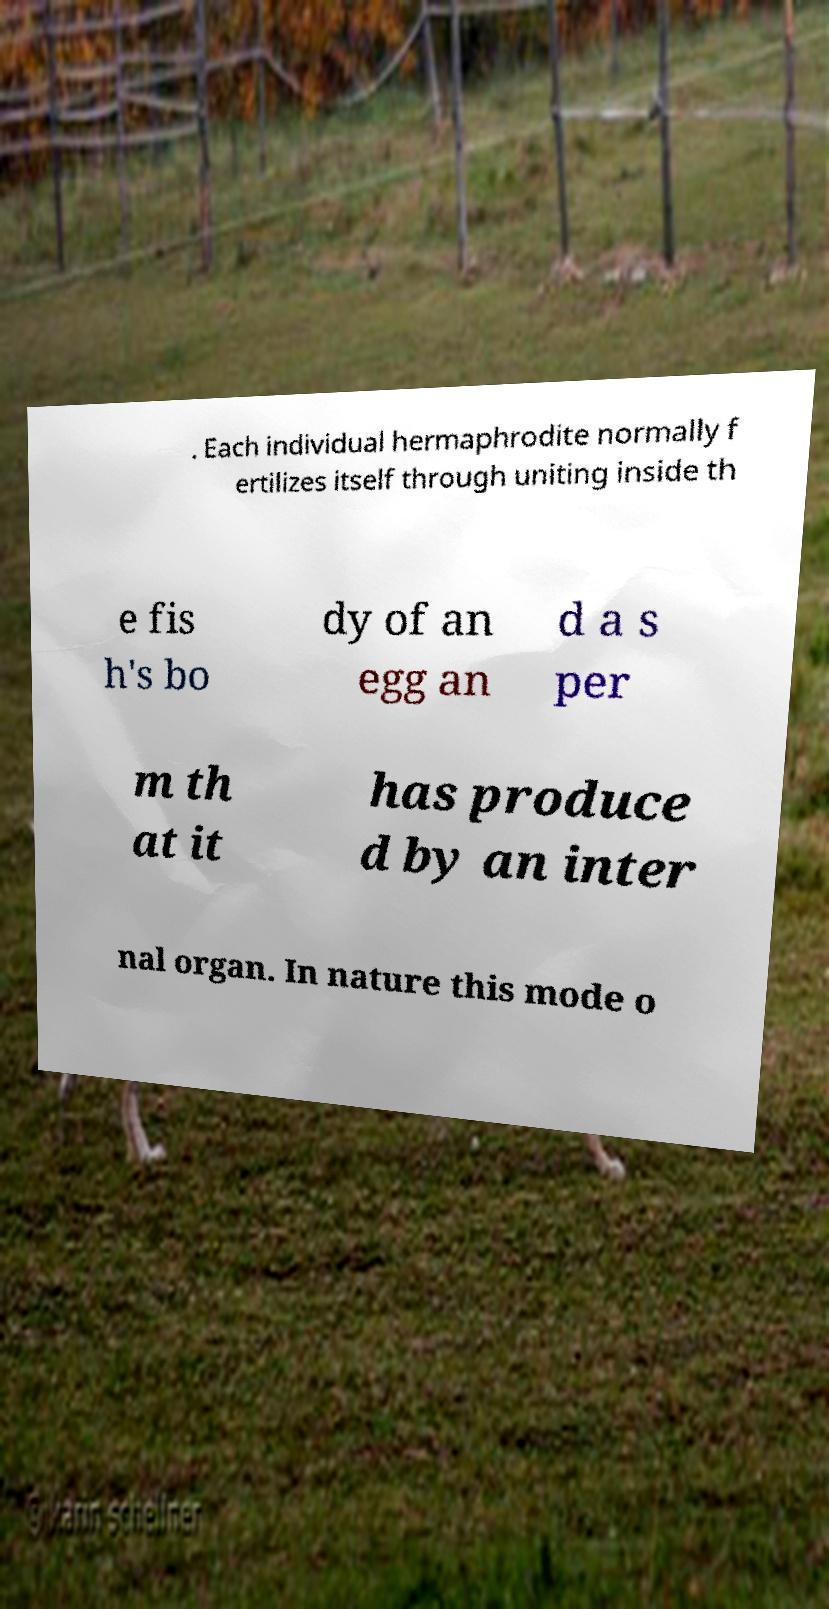What messages or text are displayed in this image? I need them in a readable, typed format. . Each individual hermaphrodite normally f ertilizes itself through uniting inside th e fis h's bo dy of an egg an d a s per m th at it has produce d by an inter nal organ. In nature this mode o 